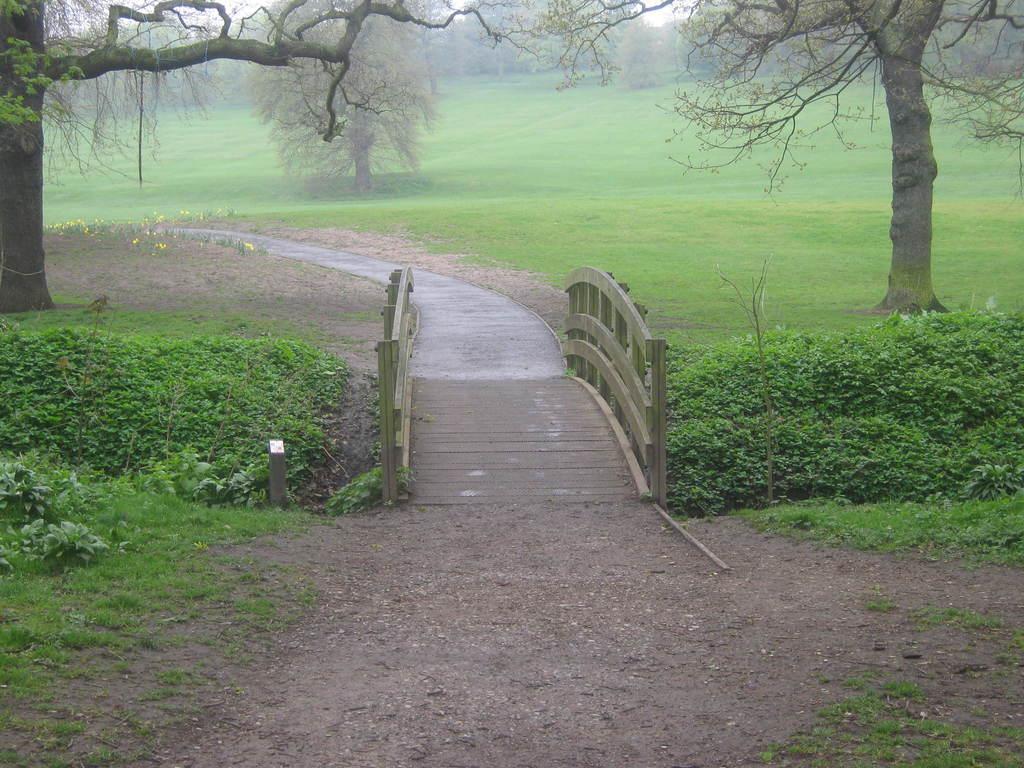How would you summarize this image in a sentence or two? In this picture we can see so many trees and grass, and beside there is a road. 